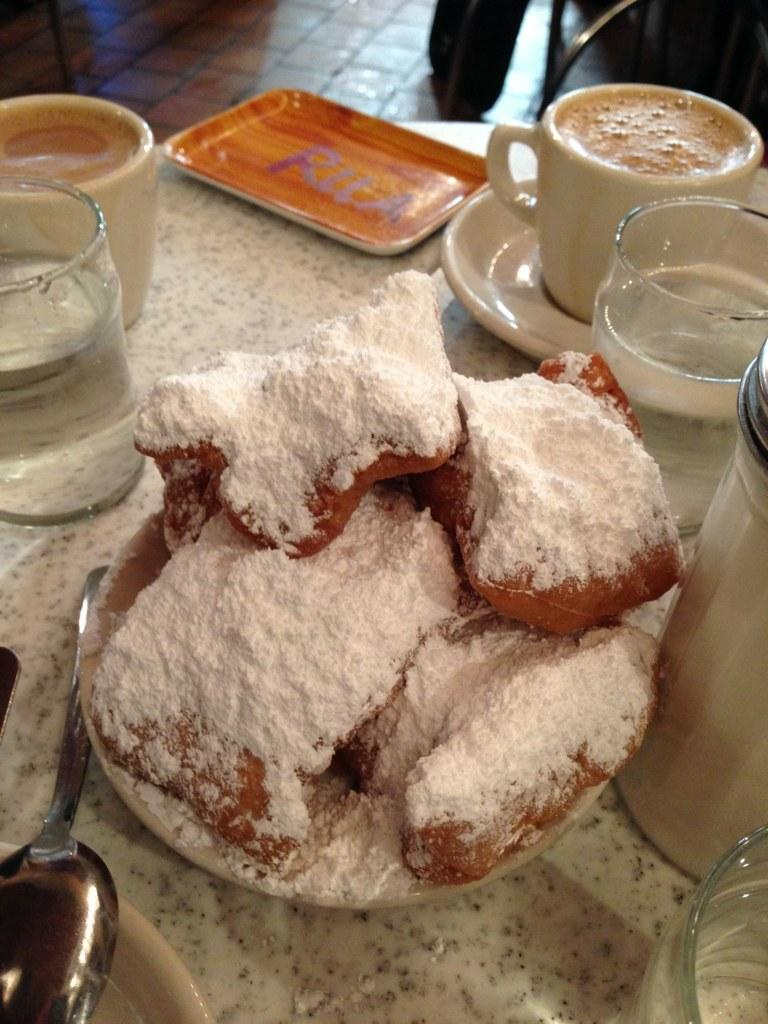What type of furniture is present in the image? There is a table and an object that looks like a chair in the image. What is placed on the table? There are plates, cups, a saucer, a bottle, spoons, and food items on the table. Can you describe the chair in the image? The chair is at the back of the image, and it is on the floor. What type of marble is visible on the island in the image? There is no marble or island present in the image; it features a table, chairs, and various tableware items. What shape is the island in the image? There is no island present in the image, so it is not possible to determine its shape. 